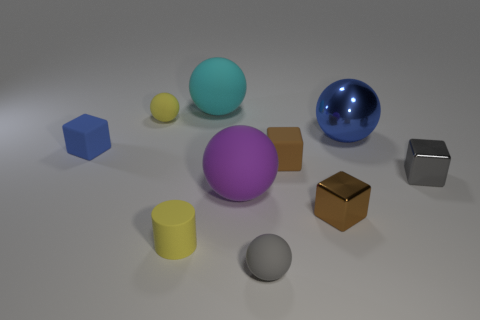Which object in the image appears to be the closest to the viewer? The grey sphere in the front appears to be the closest to the viewer, based on its size and position in the foreground. 